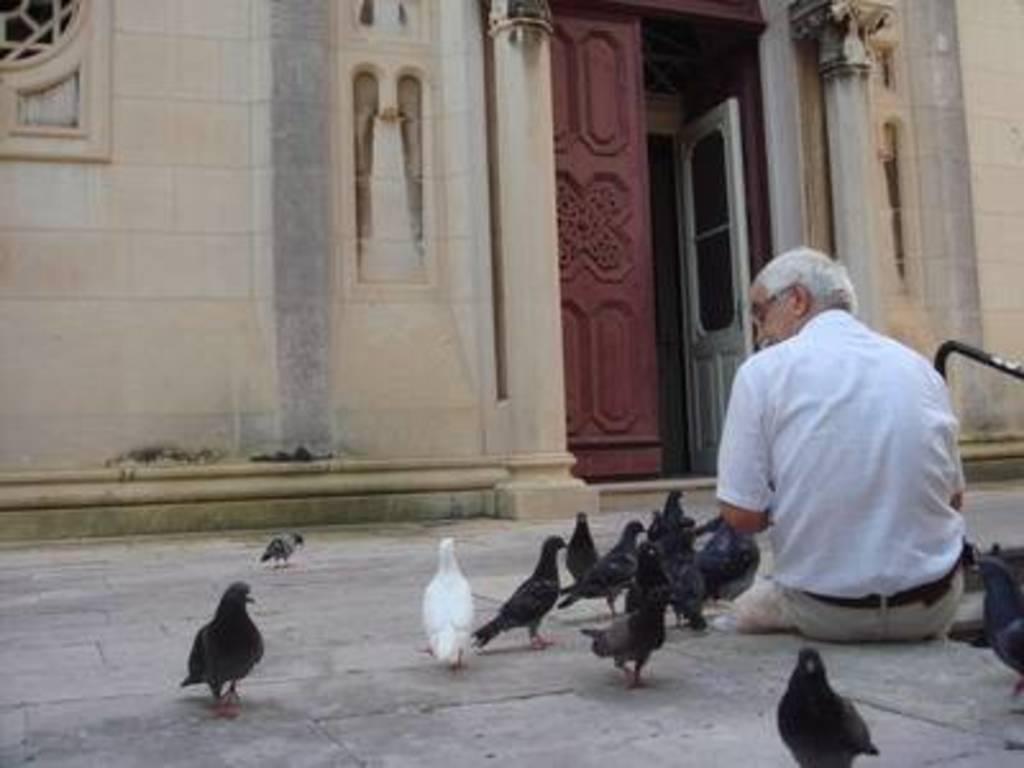Can you describe this image briefly? In the image there is a man sitting on the ground and there are many birds around the man, in the background there is some architecture and the door of that is opened. 